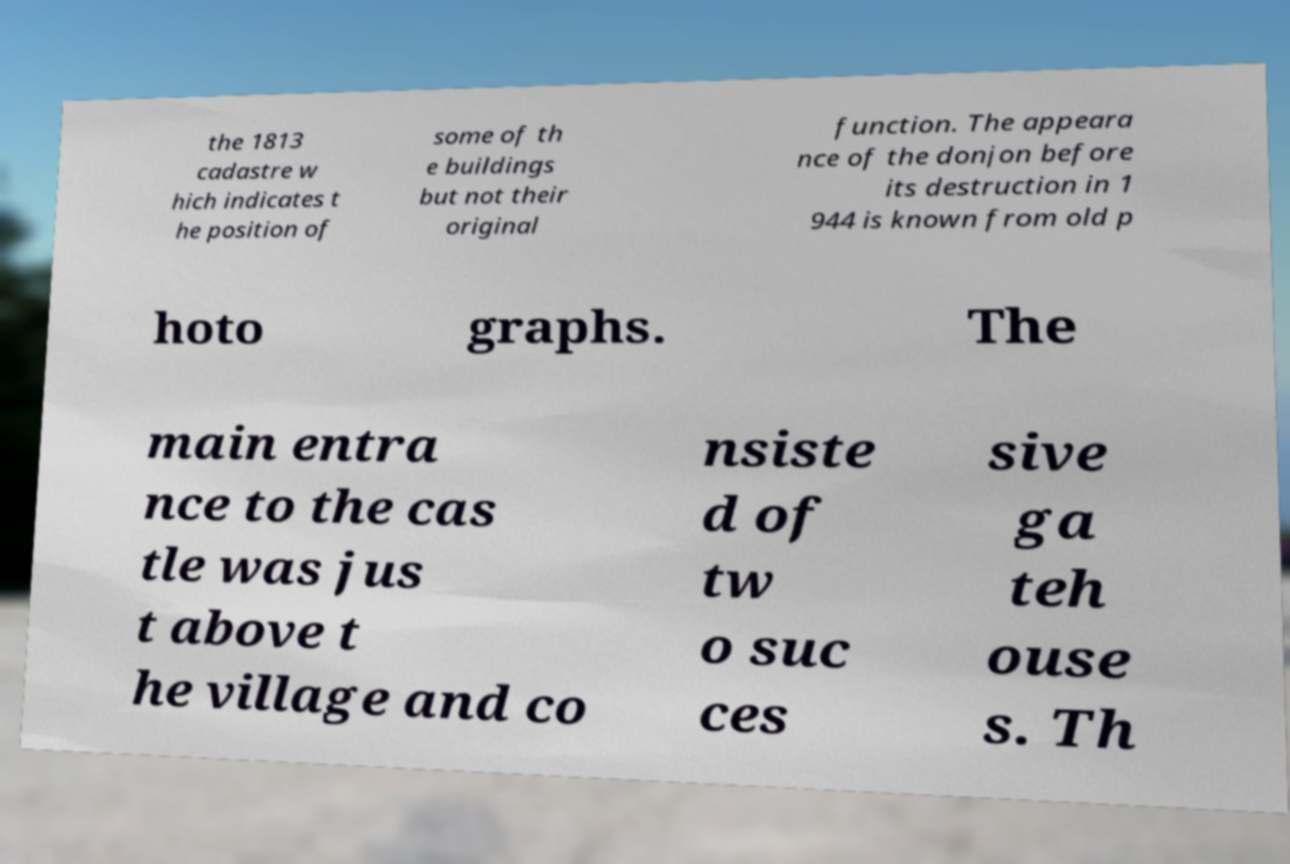Please identify and transcribe the text found in this image. the 1813 cadastre w hich indicates t he position of some of th e buildings but not their original function. The appeara nce of the donjon before its destruction in 1 944 is known from old p hoto graphs. The main entra nce to the cas tle was jus t above t he village and co nsiste d of tw o suc ces sive ga teh ouse s. Th 